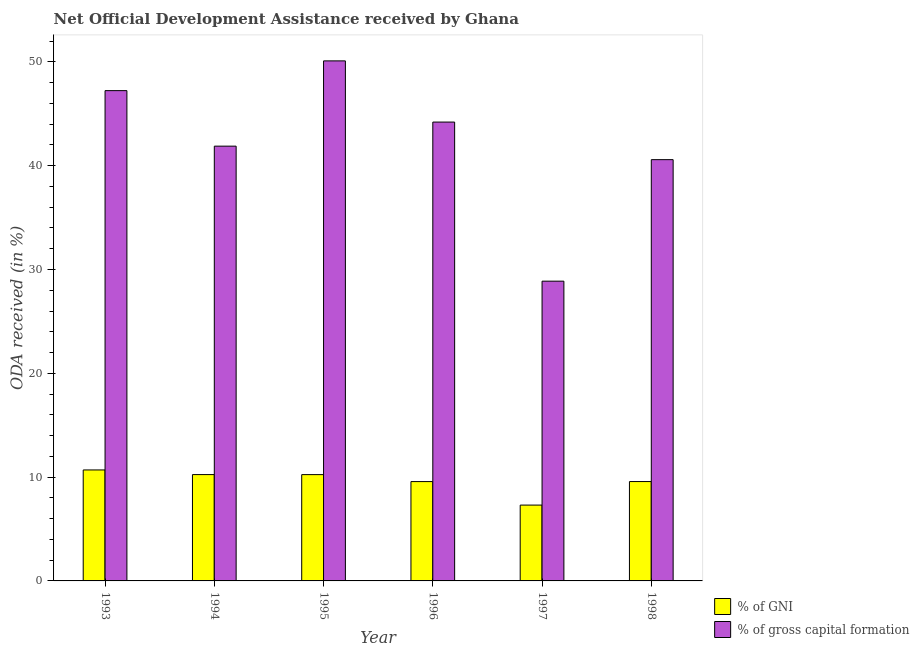How many bars are there on the 4th tick from the right?
Your answer should be very brief. 2. What is the label of the 6th group of bars from the left?
Provide a short and direct response. 1998. In how many cases, is the number of bars for a given year not equal to the number of legend labels?
Keep it short and to the point. 0. What is the oda received as percentage of gross capital formation in 1994?
Offer a very short reply. 41.88. Across all years, what is the maximum oda received as percentage of gross capital formation?
Your answer should be very brief. 50.09. Across all years, what is the minimum oda received as percentage of gni?
Your response must be concise. 7.3. In which year was the oda received as percentage of gross capital formation maximum?
Ensure brevity in your answer.  1995. What is the total oda received as percentage of gni in the graph?
Offer a very short reply. 57.62. What is the difference between the oda received as percentage of gni in 1993 and that in 1996?
Your answer should be compact. 1.12. What is the difference between the oda received as percentage of gross capital formation in 1997 and the oda received as percentage of gni in 1996?
Provide a short and direct response. -15.32. What is the average oda received as percentage of gni per year?
Your answer should be very brief. 9.6. In the year 1997, what is the difference between the oda received as percentage of gross capital formation and oda received as percentage of gni?
Your answer should be compact. 0. What is the ratio of the oda received as percentage of gross capital formation in 1993 to that in 1997?
Offer a terse response. 1.64. Is the difference between the oda received as percentage of gross capital formation in 1993 and 1996 greater than the difference between the oda received as percentage of gni in 1993 and 1996?
Give a very brief answer. No. What is the difference between the highest and the second highest oda received as percentage of gross capital formation?
Your answer should be compact. 2.87. What is the difference between the highest and the lowest oda received as percentage of gross capital formation?
Provide a succinct answer. 21.22. In how many years, is the oda received as percentage of gross capital formation greater than the average oda received as percentage of gross capital formation taken over all years?
Your answer should be compact. 3. Is the sum of the oda received as percentage of gni in 1993 and 1996 greater than the maximum oda received as percentage of gross capital formation across all years?
Make the answer very short. Yes. What does the 2nd bar from the left in 1997 represents?
Keep it short and to the point. % of gross capital formation. What does the 2nd bar from the right in 1997 represents?
Keep it short and to the point. % of GNI. How many bars are there?
Ensure brevity in your answer.  12. Are all the bars in the graph horizontal?
Provide a short and direct response. No. How many years are there in the graph?
Ensure brevity in your answer.  6. What is the difference between two consecutive major ticks on the Y-axis?
Your answer should be compact. 10. Does the graph contain any zero values?
Provide a short and direct response. No. Where does the legend appear in the graph?
Keep it short and to the point. Bottom right. How are the legend labels stacked?
Your answer should be very brief. Vertical. What is the title of the graph?
Ensure brevity in your answer.  Net Official Development Assistance received by Ghana. Does "Nitrous oxide emissions" appear as one of the legend labels in the graph?
Ensure brevity in your answer.  No. What is the label or title of the Y-axis?
Offer a very short reply. ODA received (in %). What is the ODA received (in %) in % of GNI in 1993?
Your answer should be compact. 10.69. What is the ODA received (in %) of % of gross capital formation in 1993?
Make the answer very short. 47.23. What is the ODA received (in %) of % of GNI in 1994?
Your answer should be very brief. 10.24. What is the ODA received (in %) of % of gross capital formation in 1994?
Provide a succinct answer. 41.88. What is the ODA received (in %) of % of GNI in 1995?
Make the answer very short. 10.24. What is the ODA received (in %) of % of gross capital formation in 1995?
Provide a succinct answer. 50.09. What is the ODA received (in %) in % of GNI in 1996?
Your answer should be compact. 9.57. What is the ODA received (in %) of % of gross capital formation in 1996?
Your response must be concise. 44.2. What is the ODA received (in %) in % of GNI in 1997?
Your answer should be compact. 7.3. What is the ODA received (in %) of % of gross capital formation in 1997?
Offer a very short reply. 28.88. What is the ODA received (in %) of % of GNI in 1998?
Provide a succinct answer. 9.57. What is the ODA received (in %) of % of gross capital formation in 1998?
Give a very brief answer. 40.58. Across all years, what is the maximum ODA received (in %) in % of GNI?
Offer a terse response. 10.69. Across all years, what is the maximum ODA received (in %) of % of gross capital formation?
Your answer should be very brief. 50.09. Across all years, what is the minimum ODA received (in %) in % of GNI?
Ensure brevity in your answer.  7.3. Across all years, what is the minimum ODA received (in %) of % of gross capital formation?
Offer a very short reply. 28.88. What is the total ODA received (in %) of % of GNI in the graph?
Ensure brevity in your answer.  57.62. What is the total ODA received (in %) of % of gross capital formation in the graph?
Your answer should be compact. 252.86. What is the difference between the ODA received (in %) in % of GNI in 1993 and that in 1994?
Ensure brevity in your answer.  0.45. What is the difference between the ODA received (in %) of % of gross capital formation in 1993 and that in 1994?
Provide a short and direct response. 5.35. What is the difference between the ODA received (in %) in % of GNI in 1993 and that in 1995?
Your response must be concise. 0.45. What is the difference between the ODA received (in %) of % of gross capital formation in 1993 and that in 1995?
Your response must be concise. -2.87. What is the difference between the ODA received (in %) of % of GNI in 1993 and that in 1996?
Your response must be concise. 1.12. What is the difference between the ODA received (in %) in % of gross capital formation in 1993 and that in 1996?
Your answer should be compact. 3.03. What is the difference between the ODA received (in %) in % of GNI in 1993 and that in 1997?
Your response must be concise. 3.39. What is the difference between the ODA received (in %) in % of gross capital formation in 1993 and that in 1997?
Keep it short and to the point. 18.35. What is the difference between the ODA received (in %) of % of GNI in 1993 and that in 1998?
Your answer should be very brief. 1.12. What is the difference between the ODA received (in %) in % of gross capital formation in 1993 and that in 1998?
Offer a terse response. 6.65. What is the difference between the ODA received (in %) of % of GNI in 1994 and that in 1995?
Your answer should be very brief. 0. What is the difference between the ODA received (in %) of % of gross capital formation in 1994 and that in 1995?
Provide a short and direct response. -8.21. What is the difference between the ODA received (in %) in % of GNI in 1994 and that in 1996?
Your answer should be compact. 0.67. What is the difference between the ODA received (in %) of % of gross capital formation in 1994 and that in 1996?
Your answer should be compact. -2.32. What is the difference between the ODA received (in %) of % of GNI in 1994 and that in 1997?
Provide a succinct answer. 2.94. What is the difference between the ODA received (in %) of % of gross capital formation in 1994 and that in 1997?
Your answer should be compact. 13. What is the difference between the ODA received (in %) in % of GNI in 1994 and that in 1998?
Make the answer very short. 0.67. What is the difference between the ODA received (in %) in % of gross capital formation in 1994 and that in 1998?
Your response must be concise. 1.3. What is the difference between the ODA received (in %) of % of GNI in 1995 and that in 1996?
Make the answer very short. 0.67. What is the difference between the ODA received (in %) of % of gross capital formation in 1995 and that in 1996?
Offer a very short reply. 5.89. What is the difference between the ODA received (in %) in % of GNI in 1995 and that in 1997?
Ensure brevity in your answer.  2.94. What is the difference between the ODA received (in %) of % of gross capital formation in 1995 and that in 1997?
Keep it short and to the point. 21.22. What is the difference between the ODA received (in %) in % of GNI in 1995 and that in 1998?
Ensure brevity in your answer.  0.67. What is the difference between the ODA received (in %) in % of gross capital formation in 1995 and that in 1998?
Provide a succinct answer. 9.51. What is the difference between the ODA received (in %) of % of GNI in 1996 and that in 1997?
Make the answer very short. 2.26. What is the difference between the ODA received (in %) in % of gross capital formation in 1996 and that in 1997?
Provide a succinct answer. 15.32. What is the difference between the ODA received (in %) of % of GNI in 1996 and that in 1998?
Give a very brief answer. -0. What is the difference between the ODA received (in %) in % of gross capital formation in 1996 and that in 1998?
Offer a very short reply. 3.62. What is the difference between the ODA received (in %) of % of GNI in 1997 and that in 1998?
Your answer should be very brief. -2.27. What is the difference between the ODA received (in %) of % of gross capital formation in 1997 and that in 1998?
Offer a very short reply. -11.7. What is the difference between the ODA received (in %) of % of GNI in 1993 and the ODA received (in %) of % of gross capital formation in 1994?
Provide a short and direct response. -31.19. What is the difference between the ODA received (in %) in % of GNI in 1993 and the ODA received (in %) in % of gross capital formation in 1995?
Provide a succinct answer. -39.4. What is the difference between the ODA received (in %) of % of GNI in 1993 and the ODA received (in %) of % of gross capital formation in 1996?
Keep it short and to the point. -33.51. What is the difference between the ODA received (in %) in % of GNI in 1993 and the ODA received (in %) in % of gross capital formation in 1997?
Your answer should be very brief. -18.18. What is the difference between the ODA received (in %) of % of GNI in 1993 and the ODA received (in %) of % of gross capital formation in 1998?
Your response must be concise. -29.89. What is the difference between the ODA received (in %) of % of GNI in 1994 and the ODA received (in %) of % of gross capital formation in 1995?
Offer a terse response. -39.85. What is the difference between the ODA received (in %) of % of GNI in 1994 and the ODA received (in %) of % of gross capital formation in 1996?
Give a very brief answer. -33.96. What is the difference between the ODA received (in %) of % of GNI in 1994 and the ODA received (in %) of % of gross capital formation in 1997?
Give a very brief answer. -18.63. What is the difference between the ODA received (in %) of % of GNI in 1994 and the ODA received (in %) of % of gross capital formation in 1998?
Ensure brevity in your answer.  -30.34. What is the difference between the ODA received (in %) of % of GNI in 1995 and the ODA received (in %) of % of gross capital formation in 1996?
Your response must be concise. -33.96. What is the difference between the ODA received (in %) in % of GNI in 1995 and the ODA received (in %) in % of gross capital formation in 1997?
Give a very brief answer. -18.64. What is the difference between the ODA received (in %) of % of GNI in 1995 and the ODA received (in %) of % of gross capital formation in 1998?
Make the answer very short. -30.34. What is the difference between the ODA received (in %) of % of GNI in 1996 and the ODA received (in %) of % of gross capital formation in 1997?
Provide a succinct answer. -19.31. What is the difference between the ODA received (in %) of % of GNI in 1996 and the ODA received (in %) of % of gross capital formation in 1998?
Offer a terse response. -31.01. What is the difference between the ODA received (in %) in % of GNI in 1997 and the ODA received (in %) in % of gross capital formation in 1998?
Offer a very short reply. -33.28. What is the average ODA received (in %) in % of GNI per year?
Make the answer very short. 9.6. What is the average ODA received (in %) in % of gross capital formation per year?
Give a very brief answer. 42.14. In the year 1993, what is the difference between the ODA received (in %) of % of GNI and ODA received (in %) of % of gross capital formation?
Provide a succinct answer. -36.54. In the year 1994, what is the difference between the ODA received (in %) in % of GNI and ODA received (in %) in % of gross capital formation?
Provide a succinct answer. -31.64. In the year 1995, what is the difference between the ODA received (in %) in % of GNI and ODA received (in %) in % of gross capital formation?
Give a very brief answer. -39.85. In the year 1996, what is the difference between the ODA received (in %) in % of GNI and ODA received (in %) in % of gross capital formation?
Your response must be concise. -34.63. In the year 1997, what is the difference between the ODA received (in %) in % of GNI and ODA received (in %) in % of gross capital formation?
Ensure brevity in your answer.  -21.57. In the year 1998, what is the difference between the ODA received (in %) of % of GNI and ODA received (in %) of % of gross capital formation?
Your answer should be very brief. -31.01. What is the ratio of the ODA received (in %) of % of GNI in 1993 to that in 1994?
Make the answer very short. 1.04. What is the ratio of the ODA received (in %) in % of gross capital formation in 1993 to that in 1994?
Your answer should be very brief. 1.13. What is the ratio of the ODA received (in %) in % of GNI in 1993 to that in 1995?
Your answer should be compact. 1.04. What is the ratio of the ODA received (in %) in % of gross capital formation in 1993 to that in 1995?
Your answer should be very brief. 0.94. What is the ratio of the ODA received (in %) in % of GNI in 1993 to that in 1996?
Give a very brief answer. 1.12. What is the ratio of the ODA received (in %) in % of gross capital formation in 1993 to that in 1996?
Give a very brief answer. 1.07. What is the ratio of the ODA received (in %) in % of GNI in 1993 to that in 1997?
Give a very brief answer. 1.46. What is the ratio of the ODA received (in %) of % of gross capital formation in 1993 to that in 1997?
Offer a very short reply. 1.64. What is the ratio of the ODA received (in %) in % of GNI in 1993 to that in 1998?
Ensure brevity in your answer.  1.12. What is the ratio of the ODA received (in %) of % of gross capital formation in 1993 to that in 1998?
Ensure brevity in your answer.  1.16. What is the ratio of the ODA received (in %) in % of gross capital formation in 1994 to that in 1995?
Keep it short and to the point. 0.84. What is the ratio of the ODA received (in %) of % of GNI in 1994 to that in 1996?
Make the answer very short. 1.07. What is the ratio of the ODA received (in %) in % of gross capital formation in 1994 to that in 1996?
Your response must be concise. 0.95. What is the ratio of the ODA received (in %) of % of GNI in 1994 to that in 1997?
Provide a short and direct response. 1.4. What is the ratio of the ODA received (in %) in % of gross capital formation in 1994 to that in 1997?
Provide a succinct answer. 1.45. What is the ratio of the ODA received (in %) of % of GNI in 1994 to that in 1998?
Make the answer very short. 1.07. What is the ratio of the ODA received (in %) of % of gross capital formation in 1994 to that in 1998?
Provide a succinct answer. 1.03. What is the ratio of the ODA received (in %) in % of GNI in 1995 to that in 1996?
Give a very brief answer. 1.07. What is the ratio of the ODA received (in %) of % of gross capital formation in 1995 to that in 1996?
Give a very brief answer. 1.13. What is the ratio of the ODA received (in %) in % of GNI in 1995 to that in 1997?
Keep it short and to the point. 1.4. What is the ratio of the ODA received (in %) in % of gross capital formation in 1995 to that in 1997?
Offer a very short reply. 1.73. What is the ratio of the ODA received (in %) of % of GNI in 1995 to that in 1998?
Provide a short and direct response. 1.07. What is the ratio of the ODA received (in %) of % of gross capital formation in 1995 to that in 1998?
Your answer should be very brief. 1.23. What is the ratio of the ODA received (in %) in % of GNI in 1996 to that in 1997?
Your answer should be compact. 1.31. What is the ratio of the ODA received (in %) in % of gross capital formation in 1996 to that in 1997?
Give a very brief answer. 1.53. What is the ratio of the ODA received (in %) of % of gross capital formation in 1996 to that in 1998?
Give a very brief answer. 1.09. What is the ratio of the ODA received (in %) of % of GNI in 1997 to that in 1998?
Ensure brevity in your answer.  0.76. What is the ratio of the ODA received (in %) of % of gross capital formation in 1997 to that in 1998?
Offer a very short reply. 0.71. What is the difference between the highest and the second highest ODA received (in %) of % of GNI?
Make the answer very short. 0.45. What is the difference between the highest and the second highest ODA received (in %) in % of gross capital formation?
Your answer should be very brief. 2.87. What is the difference between the highest and the lowest ODA received (in %) in % of GNI?
Offer a very short reply. 3.39. What is the difference between the highest and the lowest ODA received (in %) of % of gross capital formation?
Offer a terse response. 21.22. 